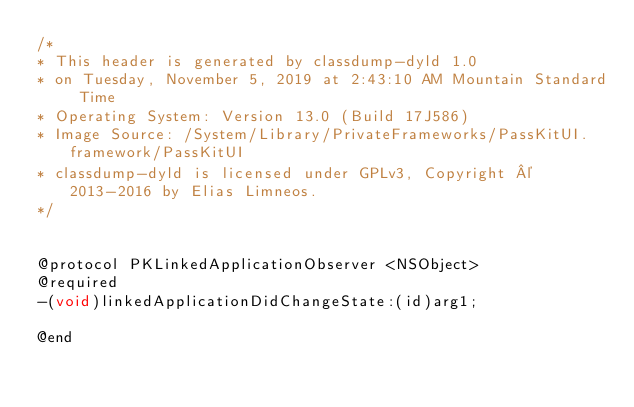<code> <loc_0><loc_0><loc_500><loc_500><_C_>/*
* This header is generated by classdump-dyld 1.0
* on Tuesday, November 5, 2019 at 2:43:10 AM Mountain Standard Time
* Operating System: Version 13.0 (Build 17J586)
* Image Source: /System/Library/PrivateFrameworks/PassKitUI.framework/PassKitUI
* classdump-dyld is licensed under GPLv3, Copyright © 2013-2016 by Elias Limneos.
*/


@protocol PKLinkedApplicationObserver <NSObject>
@required
-(void)linkedApplicationDidChangeState:(id)arg1;

@end

</code> 